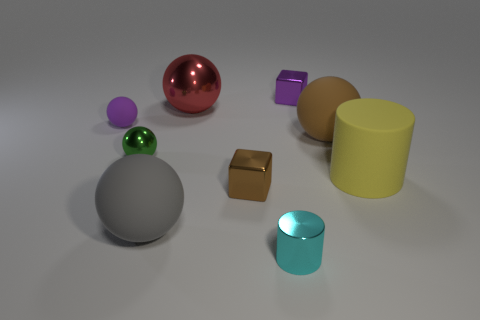Is the color of the tiny matte thing the same as the small metal thing to the right of the cyan object?
Keep it short and to the point. Yes. There is another thing that is the same color as the tiny rubber thing; what is its shape?
Provide a succinct answer. Cube. What is the color of the cylinder that is made of the same material as the gray object?
Offer a terse response. Yellow. Is the shape of the small purple metal object the same as the tiny cyan object?
Ensure brevity in your answer.  No. There is a purple metal thing that is on the right side of the cylinder that is on the left side of the tiny purple cube; is there a cylinder that is on the right side of it?
Keep it short and to the point. Yes. How many other small objects have the same color as the tiny rubber thing?
Give a very brief answer. 1. There is a brown thing that is the same size as the purple metallic block; what shape is it?
Provide a succinct answer. Cube. There is a small cyan cylinder; are there any large rubber cylinders in front of it?
Give a very brief answer. No. Does the purple metal cube have the same size as the red metallic ball?
Provide a succinct answer. No. There is a cyan metal object on the right side of the brown shiny cube; what is its shape?
Your response must be concise. Cylinder. 